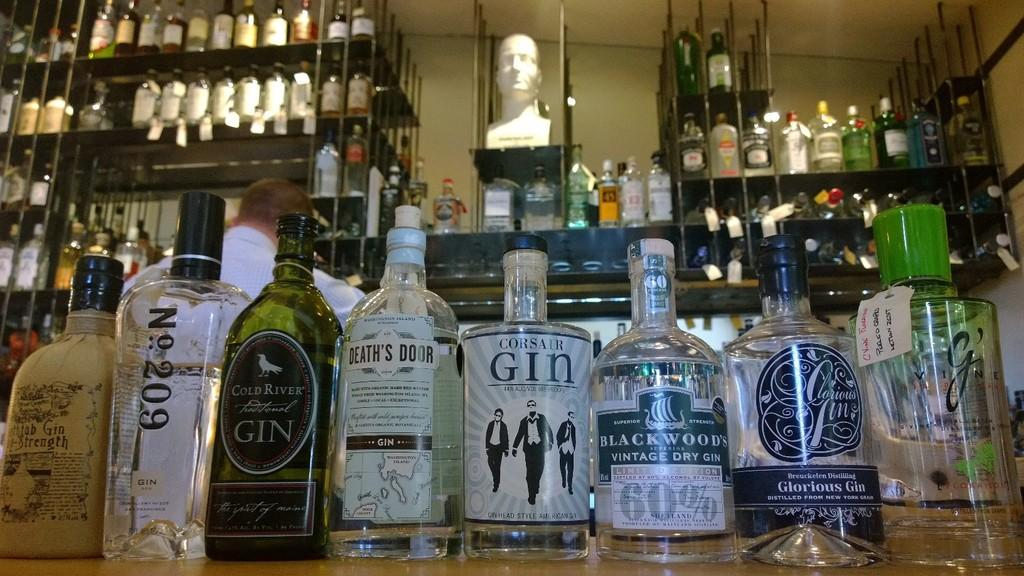<image>
Describe the image concisely. Liquor store counter with Gin bottles displayed including Cold River, Death's Door, Corsair and Blackwoods brandes. 